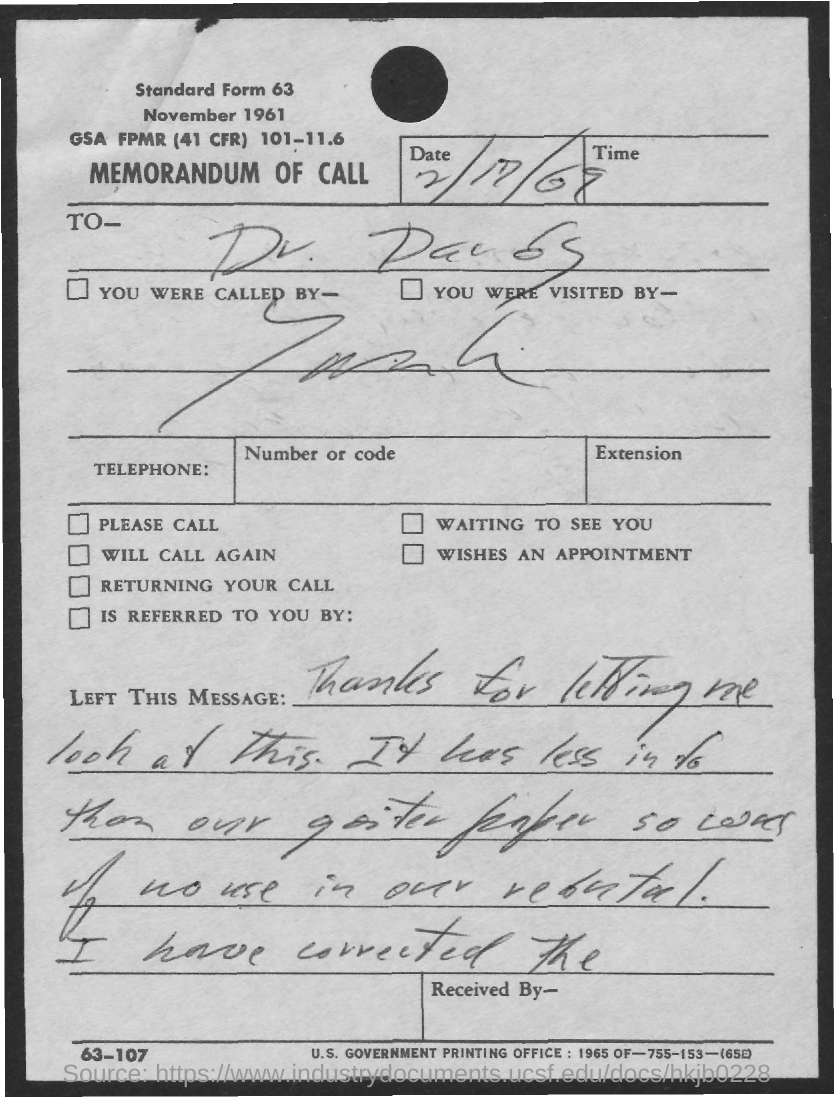What is the date mentioned ?
Provide a short and direct response. 2/17/69. 